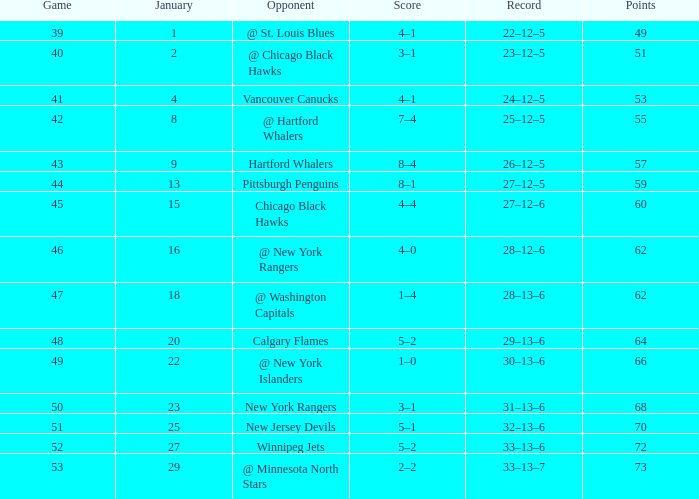Can you parse all the data within this table? {'header': ['Game', 'January', 'Opponent', 'Score', 'Record', 'Points'], 'rows': [['39', '1', '@ St. Louis Blues', '4–1', '22–12–5', '49'], ['40', '2', '@ Chicago Black Hawks', '3–1', '23–12–5', '51'], ['41', '4', 'Vancouver Canucks', '4–1', '24–12–5', '53'], ['42', '8', '@ Hartford Whalers', '7–4', '25–12–5', '55'], ['43', '9', 'Hartford Whalers', '8–4', '26–12–5', '57'], ['44', '13', 'Pittsburgh Penguins', '8–1', '27–12–5', '59'], ['45', '15', 'Chicago Black Hawks', '4–4', '27–12–6', '60'], ['46', '16', '@ New York Rangers', '4–0', '28–12–6', '62'], ['47', '18', '@ Washington Capitals', '1–4', '28–13–6', '62'], ['48', '20', 'Calgary Flames', '5–2', '29–13–6', '64'], ['49', '22', '@ New York Islanders', '1–0', '30–13–6', '66'], ['50', '23', 'New York Rangers', '3–1', '31–13–6', '68'], ['51', '25', 'New Jersey Devils', '5–1', '32–13–6', '70'], ['52', '27', 'Winnipeg Jets', '5–2', '33–13–6', '72'], ['53', '29', '@ Minnesota North Stars', '2–2', '33–13–7', '73']]} Which points possess a score of 4-1, and a game less than 39? None. 